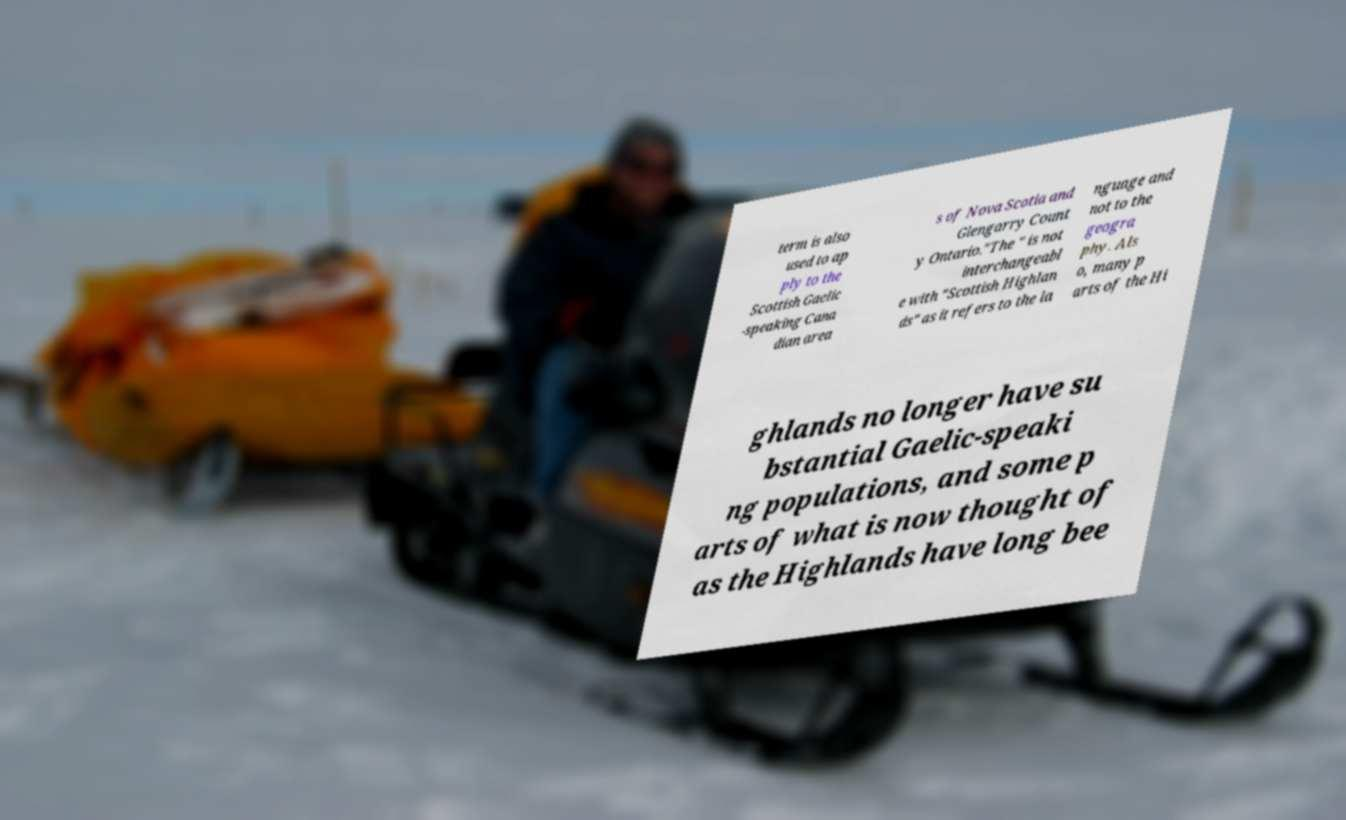Could you assist in decoding the text presented in this image and type it out clearly? term is also used to ap ply to the Scottish Gaelic -speaking Cana dian area s of Nova Scotia and Glengarry Count y Ontario."The " is not interchangeabl e with "Scottish Highlan ds" as it refers to the la nguage and not to the geogra phy. Als o, many p arts of the Hi ghlands no longer have su bstantial Gaelic-speaki ng populations, and some p arts of what is now thought of as the Highlands have long bee 